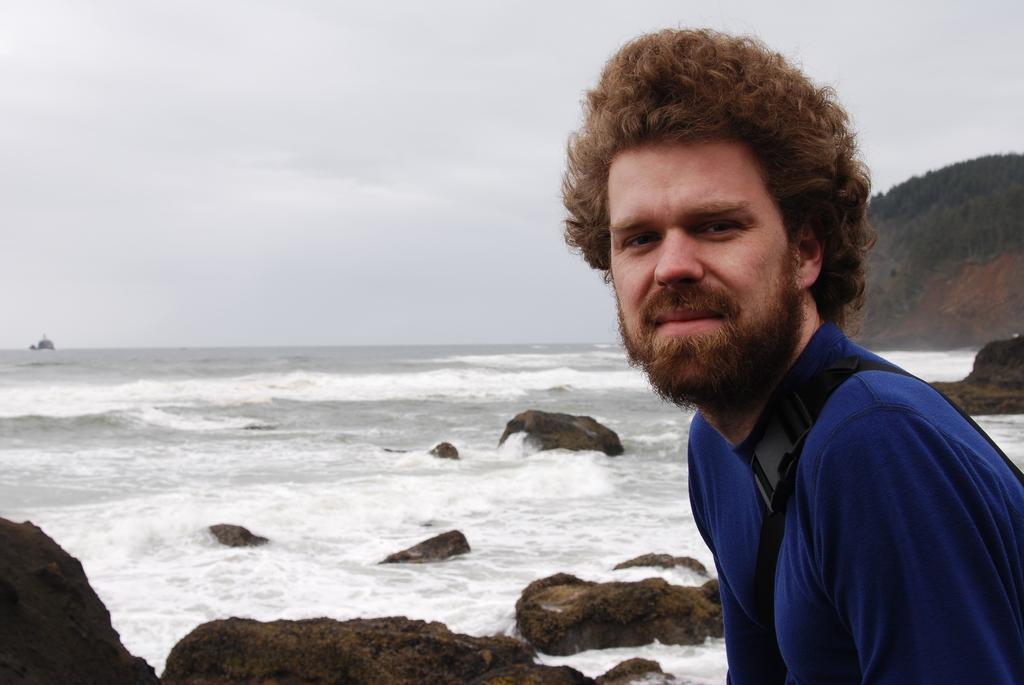In one or two sentences, can you explain what this image depicts? In the picture I can see a man wearing blue color T-shirt is on the right side of the image. Here we can see the rocks, water, hill and the cloudy sky in the background. 